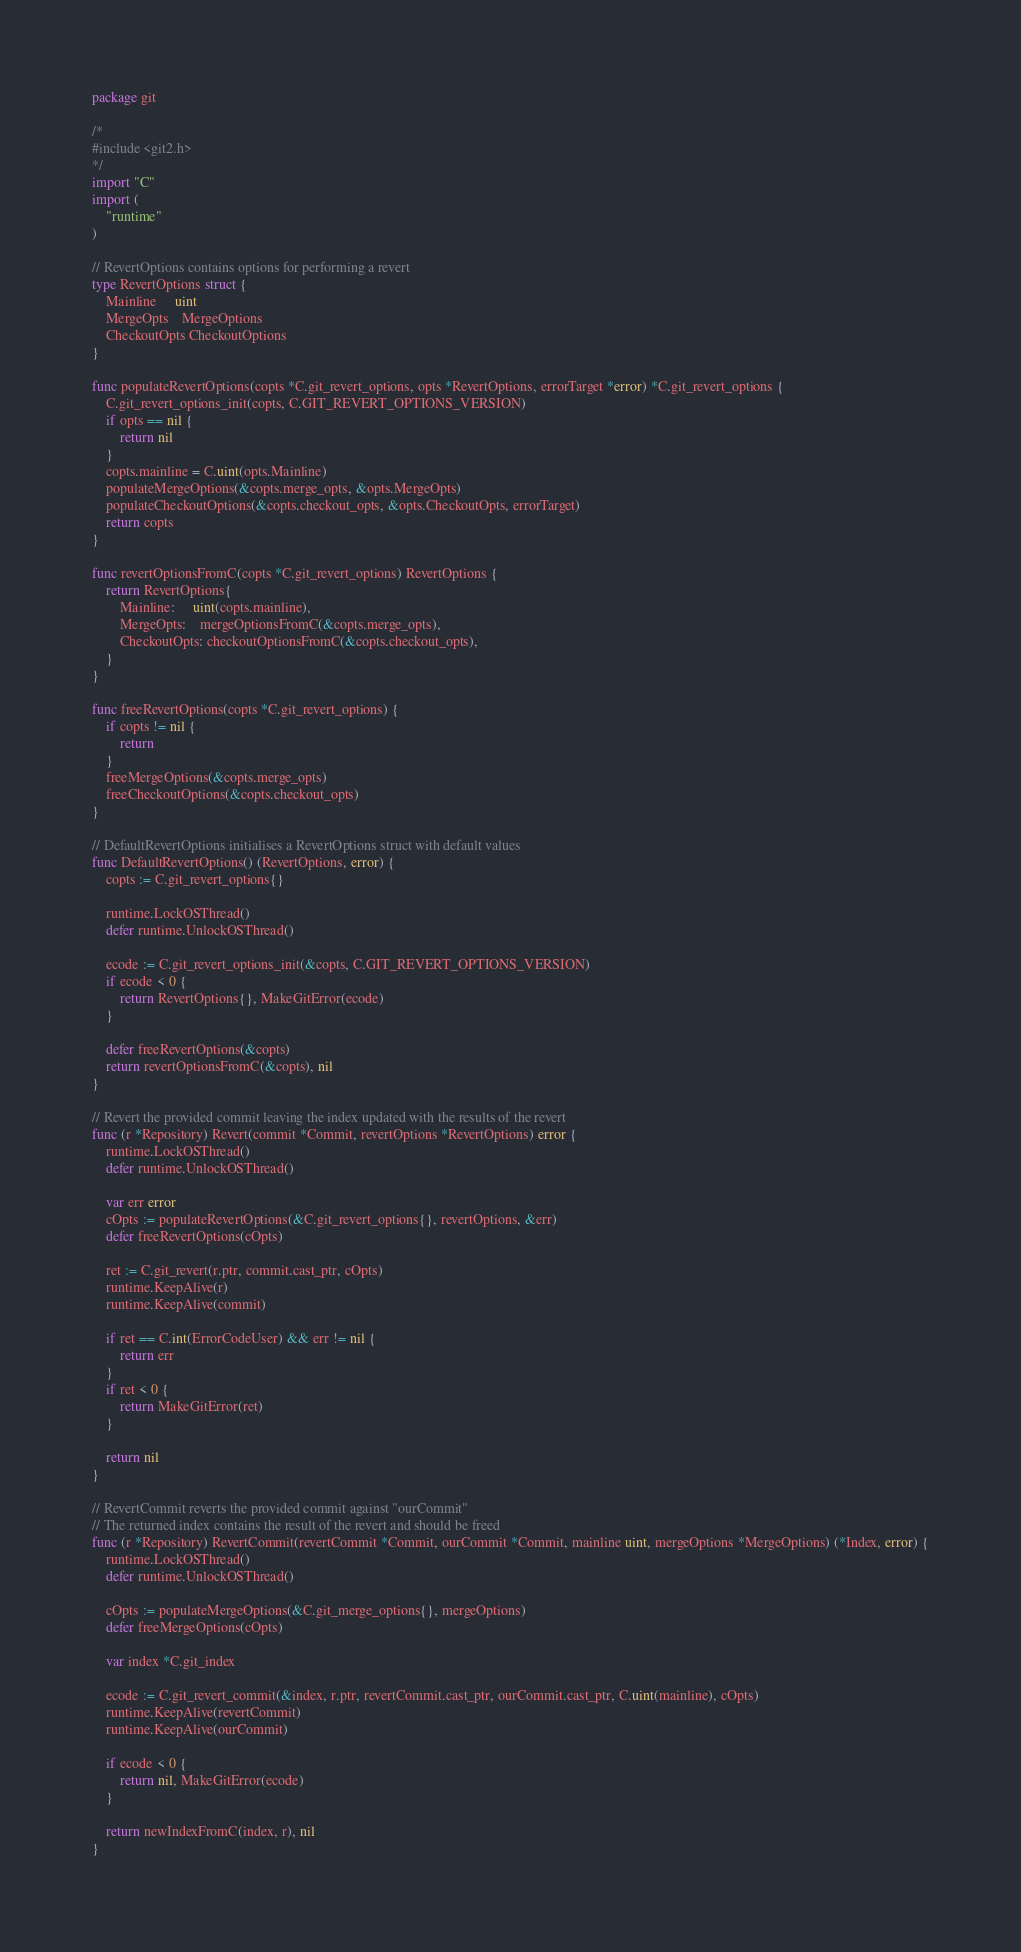Convert code to text. <code><loc_0><loc_0><loc_500><loc_500><_Go_>package git

/*
#include <git2.h>
*/
import "C"
import (
	"runtime"
)

// RevertOptions contains options for performing a revert
type RevertOptions struct {
	Mainline     uint
	MergeOpts    MergeOptions
	CheckoutOpts CheckoutOptions
}

func populateRevertOptions(copts *C.git_revert_options, opts *RevertOptions, errorTarget *error) *C.git_revert_options {
	C.git_revert_options_init(copts, C.GIT_REVERT_OPTIONS_VERSION)
	if opts == nil {
		return nil
	}
	copts.mainline = C.uint(opts.Mainline)
	populateMergeOptions(&copts.merge_opts, &opts.MergeOpts)
	populateCheckoutOptions(&copts.checkout_opts, &opts.CheckoutOpts, errorTarget)
	return copts
}

func revertOptionsFromC(copts *C.git_revert_options) RevertOptions {
	return RevertOptions{
		Mainline:     uint(copts.mainline),
		MergeOpts:    mergeOptionsFromC(&copts.merge_opts),
		CheckoutOpts: checkoutOptionsFromC(&copts.checkout_opts),
	}
}

func freeRevertOptions(copts *C.git_revert_options) {
	if copts != nil {
		return
	}
	freeMergeOptions(&copts.merge_opts)
	freeCheckoutOptions(&copts.checkout_opts)
}

// DefaultRevertOptions initialises a RevertOptions struct with default values
func DefaultRevertOptions() (RevertOptions, error) {
	copts := C.git_revert_options{}

	runtime.LockOSThread()
	defer runtime.UnlockOSThread()

	ecode := C.git_revert_options_init(&copts, C.GIT_REVERT_OPTIONS_VERSION)
	if ecode < 0 {
		return RevertOptions{}, MakeGitError(ecode)
	}

	defer freeRevertOptions(&copts)
	return revertOptionsFromC(&copts), nil
}

// Revert the provided commit leaving the index updated with the results of the revert
func (r *Repository) Revert(commit *Commit, revertOptions *RevertOptions) error {
	runtime.LockOSThread()
	defer runtime.UnlockOSThread()

	var err error
	cOpts := populateRevertOptions(&C.git_revert_options{}, revertOptions, &err)
	defer freeRevertOptions(cOpts)

	ret := C.git_revert(r.ptr, commit.cast_ptr, cOpts)
	runtime.KeepAlive(r)
	runtime.KeepAlive(commit)

	if ret == C.int(ErrorCodeUser) && err != nil {
		return err
	}
	if ret < 0 {
		return MakeGitError(ret)
	}

	return nil
}

// RevertCommit reverts the provided commit against "ourCommit"
// The returned index contains the result of the revert and should be freed
func (r *Repository) RevertCommit(revertCommit *Commit, ourCommit *Commit, mainline uint, mergeOptions *MergeOptions) (*Index, error) {
	runtime.LockOSThread()
	defer runtime.UnlockOSThread()

	cOpts := populateMergeOptions(&C.git_merge_options{}, mergeOptions)
	defer freeMergeOptions(cOpts)

	var index *C.git_index

	ecode := C.git_revert_commit(&index, r.ptr, revertCommit.cast_ptr, ourCommit.cast_ptr, C.uint(mainline), cOpts)
	runtime.KeepAlive(revertCommit)
	runtime.KeepAlive(ourCommit)

	if ecode < 0 {
		return nil, MakeGitError(ecode)
	}

	return newIndexFromC(index, r), nil
}
</code> 